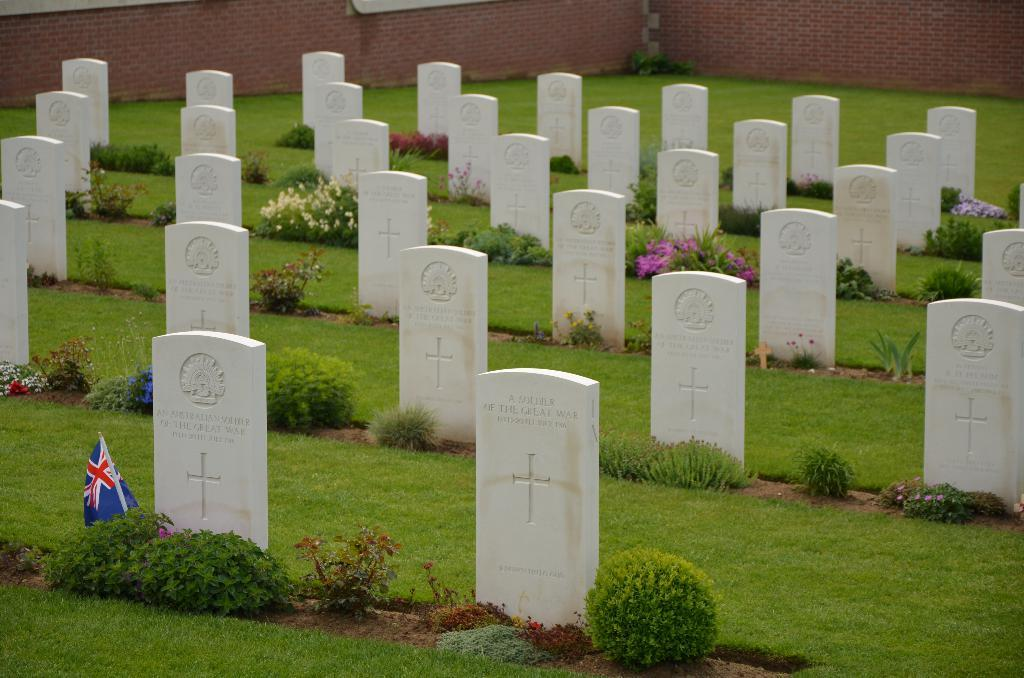What is located on the left side of the image? There is a flag on the left side of the image. What can be seen in the middle of the image? There are graves and bushes in the middle of the image. What is visible at the top of the image? There are walls visible at the top of the image. How many passengers are sitting inside the building in the image? There is no building or passengers present in the image. What type of expert can be seen giving a lecture in the image? There is no expert or lecture present in the image. 